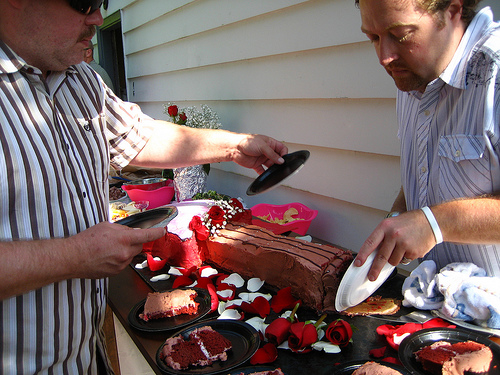<image>
Is there a food on the table? Yes. Looking at the image, I can see the food is positioned on top of the table, with the table providing support. Where is the paper plate in relation to the cake? Is it to the right of the cake? Yes. From this viewpoint, the paper plate is positioned to the right side relative to the cake. 